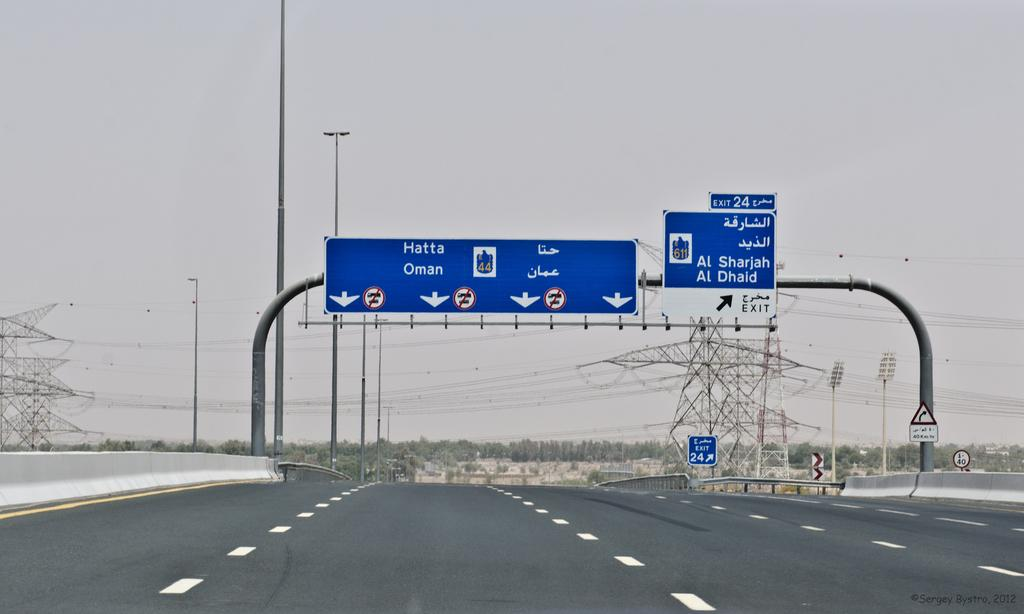What is the main object in the center of the image? There is a sign board in the center of the image. What type of infrastructure can be seen in the image? There is a road in the image. What can be seen in the background of the image? There are electric towers, street lights, and trees in the background of the image. Can you see any brass instruments being played by a laborer near the sea in the image? There is no brass instrument, laborer, or sea present in the image. 